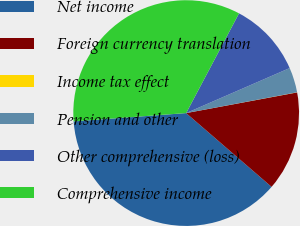<chart> <loc_0><loc_0><loc_500><loc_500><pie_chart><fcel>Net income<fcel>Foreign currency translation<fcel>Income tax effect<fcel>Pension and other<fcel>Other comprehensive (loss)<fcel>Comprehensive income<nl><fcel>37.49%<fcel>14.27%<fcel>0.02%<fcel>3.58%<fcel>10.71%<fcel>33.93%<nl></chart> 